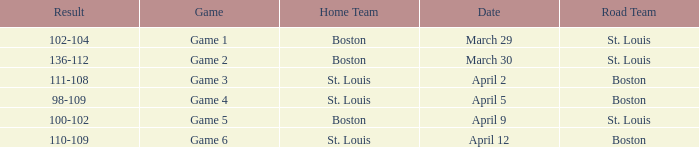What is the Game number on March 30? Game 2. 